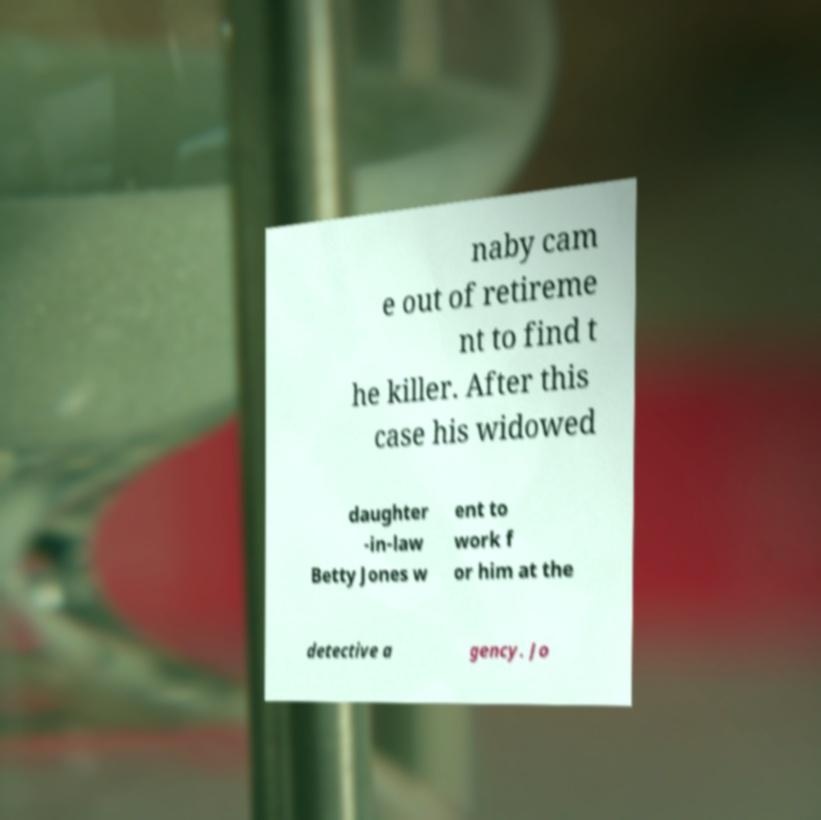I need the written content from this picture converted into text. Can you do that? naby cam e out of retireme nt to find t he killer. After this case his widowed daughter -in-law Betty Jones w ent to work f or him at the detective a gency. Jo 